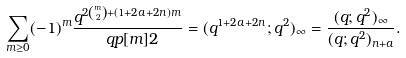<formula> <loc_0><loc_0><loc_500><loc_500>\sum _ { m \geq 0 } ( - 1 ) ^ { m } \frac { q ^ { 2 \binom { m } { 2 } + ( 1 + 2 a + 2 n ) m } } { \ q p [ m ] { 2 } } = ( q ^ { 1 + 2 a + 2 n } ; q ^ { 2 } ) _ { \infty } = \frac { ( q ; q ^ { 2 } ) _ { \infty } } { ( q ; q ^ { 2 } ) _ { n + a } } .</formula> 